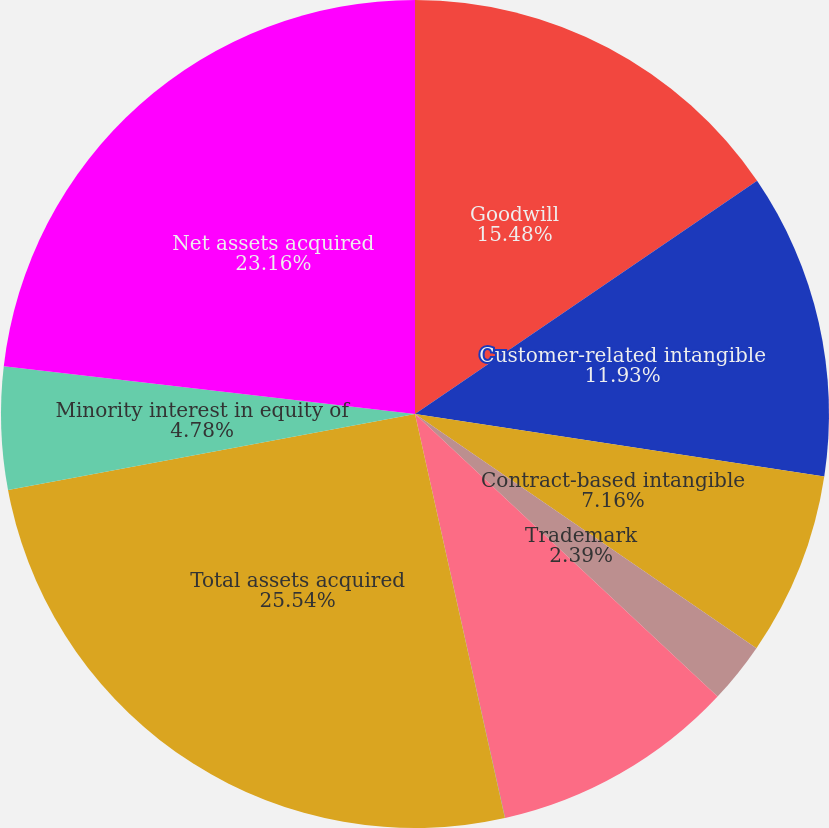<chart> <loc_0><loc_0><loc_500><loc_500><pie_chart><fcel>Goodwill<fcel>Customer-related intangible<fcel>Contract-based intangible<fcel>Trademark<fcel>Property and equipment<fcel>Other current assets<fcel>Total assets acquired<fcel>Minority interest in equity of<fcel>Net assets acquired<nl><fcel>15.48%<fcel>11.93%<fcel>7.16%<fcel>2.39%<fcel>9.55%<fcel>0.01%<fcel>25.55%<fcel>4.78%<fcel>23.16%<nl></chart> 